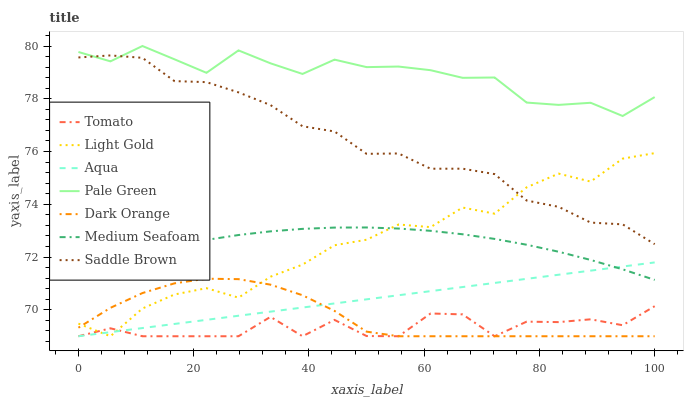Does Dark Orange have the minimum area under the curve?
Answer yes or no. No. Does Dark Orange have the maximum area under the curve?
Answer yes or no. No. Is Dark Orange the smoothest?
Answer yes or no. No. Is Dark Orange the roughest?
Answer yes or no. No. Does Saddle Brown have the lowest value?
Answer yes or no. No. Does Dark Orange have the highest value?
Answer yes or no. No. Is Aqua less than Pale Green?
Answer yes or no. Yes. Is Pale Green greater than Tomato?
Answer yes or no. Yes. Does Aqua intersect Pale Green?
Answer yes or no. No. 